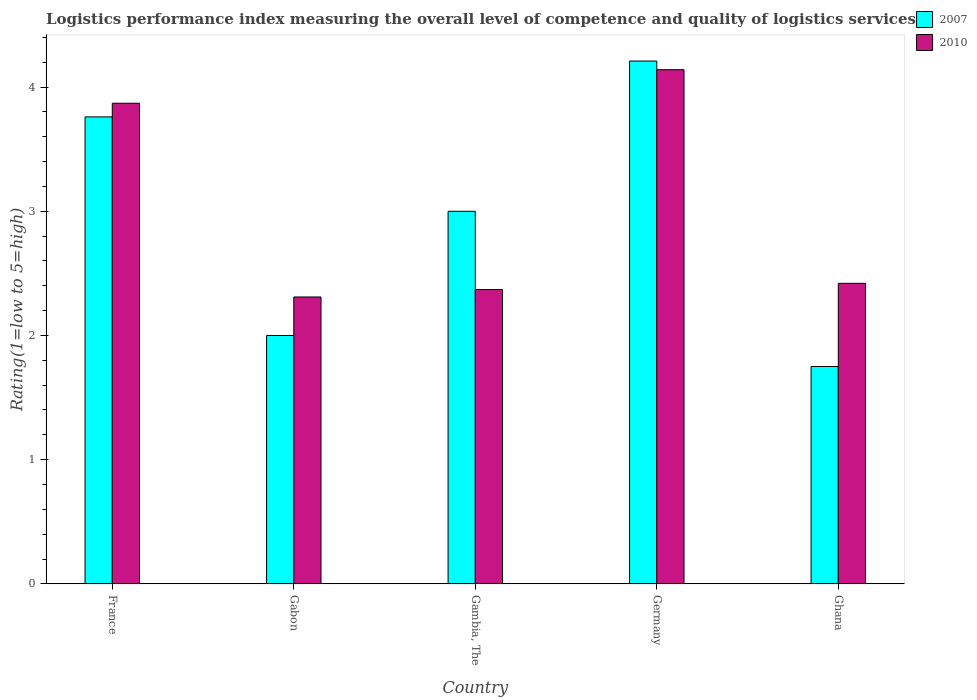How many groups of bars are there?
Provide a succinct answer. 5. How many bars are there on the 3rd tick from the left?
Give a very brief answer. 2. How many bars are there on the 4th tick from the right?
Offer a very short reply. 2. What is the Logistic performance index in 2007 in France?
Provide a succinct answer. 3.76. Across all countries, what is the maximum Logistic performance index in 2010?
Your answer should be very brief. 4.14. Across all countries, what is the minimum Logistic performance index in 2010?
Provide a short and direct response. 2.31. In which country was the Logistic performance index in 2007 maximum?
Your answer should be compact. Germany. What is the total Logistic performance index in 2007 in the graph?
Make the answer very short. 14.72. What is the difference between the Logistic performance index in 2007 in France and that in Ghana?
Offer a very short reply. 2.01. What is the difference between the Logistic performance index in 2007 in Germany and the Logistic performance index in 2010 in Gambia, The?
Provide a succinct answer. 1.84. What is the average Logistic performance index in 2007 per country?
Your answer should be compact. 2.94. What is the difference between the Logistic performance index of/in 2010 and Logistic performance index of/in 2007 in Germany?
Give a very brief answer. -0.07. What is the ratio of the Logistic performance index in 2007 in Gabon to that in Gambia, The?
Keep it short and to the point. 0.67. What is the difference between the highest and the second highest Logistic performance index in 2010?
Ensure brevity in your answer.  -1.45. What is the difference between the highest and the lowest Logistic performance index in 2010?
Keep it short and to the point. 1.83. Is the sum of the Logistic performance index in 2007 in Gambia, The and Germany greater than the maximum Logistic performance index in 2010 across all countries?
Your response must be concise. Yes. Are all the bars in the graph horizontal?
Offer a very short reply. No. What is the difference between two consecutive major ticks on the Y-axis?
Offer a very short reply. 1. Are the values on the major ticks of Y-axis written in scientific E-notation?
Offer a terse response. No. Does the graph contain any zero values?
Make the answer very short. No. Does the graph contain grids?
Offer a terse response. No. What is the title of the graph?
Offer a very short reply. Logistics performance index measuring the overall level of competence and quality of logistics services. Does "2007" appear as one of the legend labels in the graph?
Provide a short and direct response. Yes. What is the label or title of the X-axis?
Keep it short and to the point. Country. What is the label or title of the Y-axis?
Provide a short and direct response. Rating(1=low to 5=high). What is the Rating(1=low to 5=high) in 2007 in France?
Provide a short and direct response. 3.76. What is the Rating(1=low to 5=high) of 2010 in France?
Offer a very short reply. 3.87. What is the Rating(1=low to 5=high) in 2007 in Gabon?
Offer a terse response. 2. What is the Rating(1=low to 5=high) in 2010 in Gabon?
Offer a very short reply. 2.31. What is the Rating(1=low to 5=high) in 2007 in Gambia, The?
Ensure brevity in your answer.  3. What is the Rating(1=low to 5=high) of 2010 in Gambia, The?
Keep it short and to the point. 2.37. What is the Rating(1=low to 5=high) in 2007 in Germany?
Ensure brevity in your answer.  4.21. What is the Rating(1=low to 5=high) in 2010 in Germany?
Your answer should be very brief. 4.14. What is the Rating(1=low to 5=high) in 2007 in Ghana?
Your response must be concise. 1.75. What is the Rating(1=low to 5=high) in 2010 in Ghana?
Make the answer very short. 2.42. Across all countries, what is the maximum Rating(1=low to 5=high) in 2007?
Keep it short and to the point. 4.21. Across all countries, what is the maximum Rating(1=low to 5=high) in 2010?
Provide a succinct answer. 4.14. Across all countries, what is the minimum Rating(1=low to 5=high) of 2007?
Offer a very short reply. 1.75. Across all countries, what is the minimum Rating(1=low to 5=high) of 2010?
Keep it short and to the point. 2.31. What is the total Rating(1=low to 5=high) in 2007 in the graph?
Make the answer very short. 14.72. What is the total Rating(1=low to 5=high) in 2010 in the graph?
Your answer should be compact. 15.11. What is the difference between the Rating(1=low to 5=high) in 2007 in France and that in Gabon?
Provide a succinct answer. 1.76. What is the difference between the Rating(1=low to 5=high) of 2010 in France and that in Gabon?
Provide a succinct answer. 1.56. What is the difference between the Rating(1=low to 5=high) in 2007 in France and that in Gambia, The?
Make the answer very short. 0.76. What is the difference between the Rating(1=low to 5=high) of 2010 in France and that in Gambia, The?
Your answer should be compact. 1.5. What is the difference between the Rating(1=low to 5=high) of 2007 in France and that in Germany?
Offer a very short reply. -0.45. What is the difference between the Rating(1=low to 5=high) of 2010 in France and that in Germany?
Your answer should be compact. -0.27. What is the difference between the Rating(1=low to 5=high) in 2007 in France and that in Ghana?
Make the answer very short. 2.01. What is the difference between the Rating(1=low to 5=high) of 2010 in France and that in Ghana?
Give a very brief answer. 1.45. What is the difference between the Rating(1=low to 5=high) in 2010 in Gabon and that in Gambia, The?
Your answer should be compact. -0.06. What is the difference between the Rating(1=low to 5=high) in 2007 in Gabon and that in Germany?
Your answer should be compact. -2.21. What is the difference between the Rating(1=low to 5=high) in 2010 in Gabon and that in Germany?
Make the answer very short. -1.83. What is the difference between the Rating(1=low to 5=high) of 2010 in Gabon and that in Ghana?
Provide a short and direct response. -0.11. What is the difference between the Rating(1=low to 5=high) of 2007 in Gambia, The and that in Germany?
Offer a terse response. -1.21. What is the difference between the Rating(1=low to 5=high) in 2010 in Gambia, The and that in Germany?
Your answer should be compact. -1.77. What is the difference between the Rating(1=low to 5=high) of 2007 in Gambia, The and that in Ghana?
Offer a terse response. 1.25. What is the difference between the Rating(1=low to 5=high) of 2007 in Germany and that in Ghana?
Make the answer very short. 2.46. What is the difference between the Rating(1=low to 5=high) in 2010 in Germany and that in Ghana?
Make the answer very short. 1.72. What is the difference between the Rating(1=low to 5=high) of 2007 in France and the Rating(1=low to 5=high) of 2010 in Gabon?
Give a very brief answer. 1.45. What is the difference between the Rating(1=low to 5=high) in 2007 in France and the Rating(1=low to 5=high) in 2010 in Gambia, The?
Give a very brief answer. 1.39. What is the difference between the Rating(1=low to 5=high) of 2007 in France and the Rating(1=low to 5=high) of 2010 in Germany?
Offer a terse response. -0.38. What is the difference between the Rating(1=low to 5=high) of 2007 in France and the Rating(1=low to 5=high) of 2010 in Ghana?
Ensure brevity in your answer.  1.34. What is the difference between the Rating(1=low to 5=high) in 2007 in Gabon and the Rating(1=low to 5=high) in 2010 in Gambia, The?
Your answer should be compact. -0.37. What is the difference between the Rating(1=low to 5=high) of 2007 in Gabon and the Rating(1=low to 5=high) of 2010 in Germany?
Your answer should be compact. -2.14. What is the difference between the Rating(1=low to 5=high) of 2007 in Gabon and the Rating(1=low to 5=high) of 2010 in Ghana?
Make the answer very short. -0.42. What is the difference between the Rating(1=low to 5=high) in 2007 in Gambia, The and the Rating(1=low to 5=high) in 2010 in Germany?
Offer a very short reply. -1.14. What is the difference between the Rating(1=low to 5=high) in 2007 in Gambia, The and the Rating(1=low to 5=high) in 2010 in Ghana?
Ensure brevity in your answer.  0.58. What is the difference between the Rating(1=low to 5=high) of 2007 in Germany and the Rating(1=low to 5=high) of 2010 in Ghana?
Give a very brief answer. 1.79. What is the average Rating(1=low to 5=high) of 2007 per country?
Offer a terse response. 2.94. What is the average Rating(1=low to 5=high) of 2010 per country?
Your answer should be very brief. 3.02. What is the difference between the Rating(1=low to 5=high) in 2007 and Rating(1=low to 5=high) in 2010 in France?
Your answer should be very brief. -0.11. What is the difference between the Rating(1=low to 5=high) in 2007 and Rating(1=low to 5=high) in 2010 in Gabon?
Provide a short and direct response. -0.31. What is the difference between the Rating(1=low to 5=high) in 2007 and Rating(1=low to 5=high) in 2010 in Gambia, The?
Offer a terse response. 0.63. What is the difference between the Rating(1=low to 5=high) of 2007 and Rating(1=low to 5=high) of 2010 in Germany?
Your answer should be very brief. 0.07. What is the difference between the Rating(1=low to 5=high) of 2007 and Rating(1=low to 5=high) of 2010 in Ghana?
Your answer should be very brief. -0.67. What is the ratio of the Rating(1=low to 5=high) of 2007 in France to that in Gabon?
Your response must be concise. 1.88. What is the ratio of the Rating(1=low to 5=high) in 2010 in France to that in Gabon?
Your answer should be compact. 1.68. What is the ratio of the Rating(1=low to 5=high) in 2007 in France to that in Gambia, The?
Your answer should be very brief. 1.25. What is the ratio of the Rating(1=low to 5=high) in 2010 in France to that in Gambia, The?
Provide a short and direct response. 1.63. What is the ratio of the Rating(1=low to 5=high) of 2007 in France to that in Germany?
Provide a short and direct response. 0.89. What is the ratio of the Rating(1=low to 5=high) of 2010 in France to that in Germany?
Keep it short and to the point. 0.93. What is the ratio of the Rating(1=low to 5=high) in 2007 in France to that in Ghana?
Your response must be concise. 2.15. What is the ratio of the Rating(1=low to 5=high) of 2010 in France to that in Ghana?
Provide a succinct answer. 1.6. What is the ratio of the Rating(1=low to 5=high) of 2010 in Gabon to that in Gambia, The?
Provide a short and direct response. 0.97. What is the ratio of the Rating(1=low to 5=high) of 2007 in Gabon to that in Germany?
Ensure brevity in your answer.  0.48. What is the ratio of the Rating(1=low to 5=high) of 2010 in Gabon to that in Germany?
Offer a terse response. 0.56. What is the ratio of the Rating(1=low to 5=high) of 2010 in Gabon to that in Ghana?
Offer a very short reply. 0.95. What is the ratio of the Rating(1=low to 5=high) in 2007 in Gambia, The to that in Germany?
Offer a terse response. 0.71. What is the ratio of the Rating(1=low to 5=high) in 2010 in Gambia, The to that in Germany?
Keep it short and to the point. 0.57. What is the ratio of the Rating(1=low to 5=high) in 2007 in Gambia, The to that in Ghana?
Your response must be concise. 1.71. What is the ratio of the Rating(1=low to 5=high) in 2010 in Gambia, The to that in Ghana?
Your answer should be very brief. 0.98. What is the ratio of the Rating(1=low to 5=high) in 2007 in Germany to that in Ghana?
Ensure brevity in your answer.  2.41. What is the ratio of the Rating(1=low to 5=high) of 2010 in Germany to that in Ghana?
Provide a short and direct response. 1.71. What is the difference between the highest and the second highest Rating(1=low to 5=high) of 2007?
Keep it short and to the point. 0.45. What is the difference between the highest and the second highest Rating(1=low to 5=high) of 2010?
Ensure brevity in your answer.  0.27. What is the difference between the highest and the lowest Rating(1=low to 5=high) in 2007?
Keep it short and to the point. 2.46. What is the difference between the highest and the lowest Rating(1=low to 5=high) in 2010?
Give a very brief answer. 1.83. 